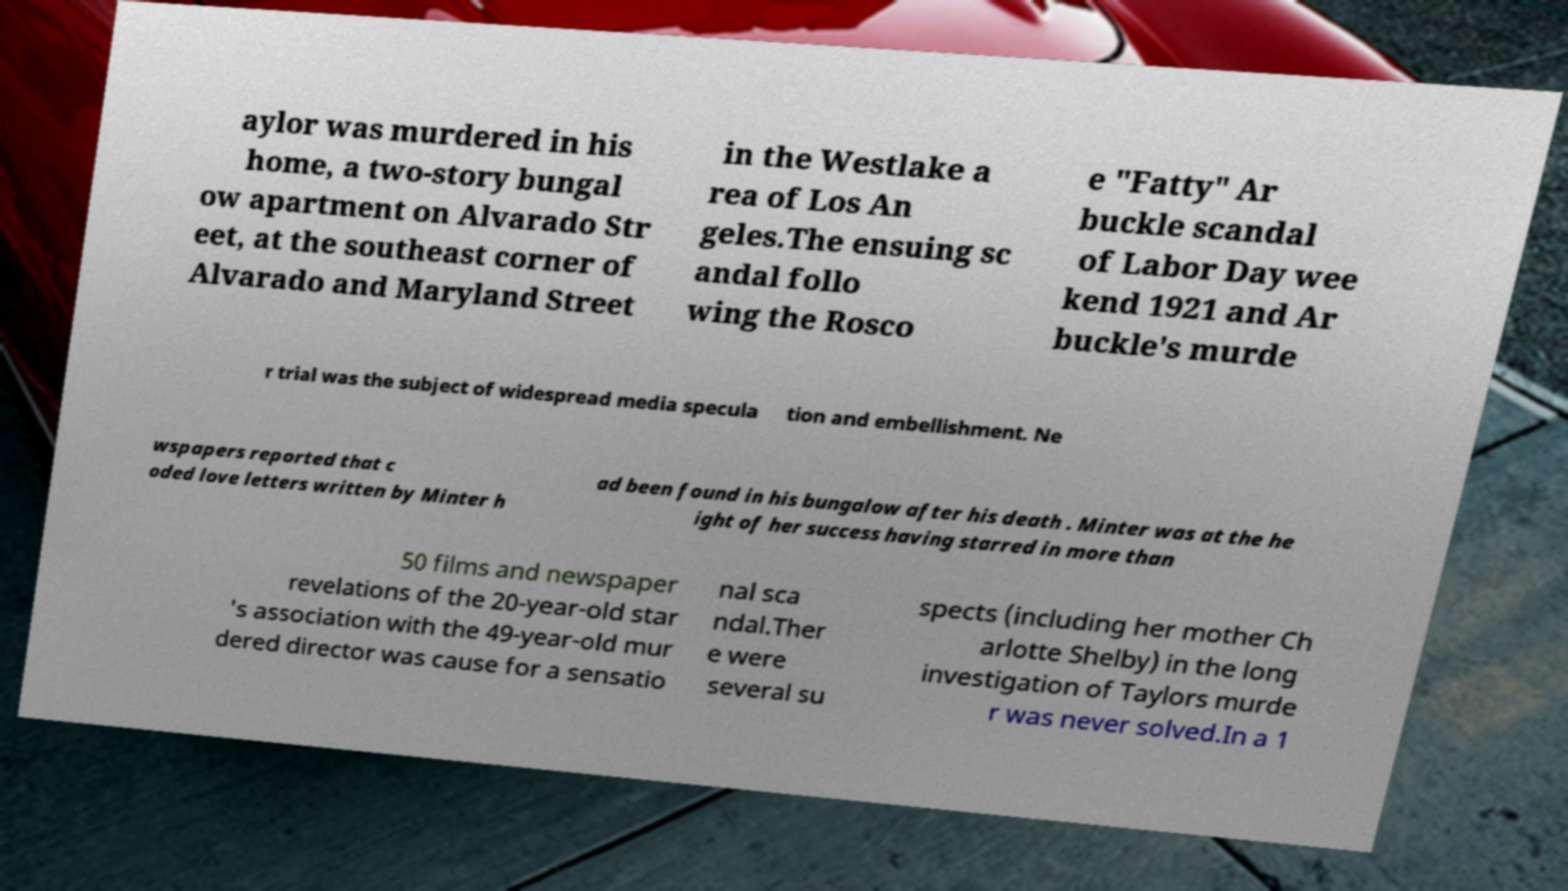Could you extract and type out the text from this image? aylor was murdered in his home, a two-story bungal ow apartment on Alvarado Str eet, at the southeast corner of Alvarado and Maryland Street in the Westlake a rea of Los An geles.The ensuing sc andal follo wing the Rosco e "Fatty" Ar buckle scandal of Labor Day wee kend 1921 and Ar buckle's murde r trial was the subject of widespread media specula tion and embellishment. Ne wspapers reported that c oded love letters written by Minter h ad been found in his bungalow after his death . Minter was at the he ight of her success having starred in more than 50 films and newspaper revelations of the 20-year-old star 's association with the 49-year-old mur dered director was cause for a sensatio nal sca ndal.Ther e were several su spects (including her mother Ch arlotte Shelby) in the long investigation of Taylors murde r was never solved.In a 1 